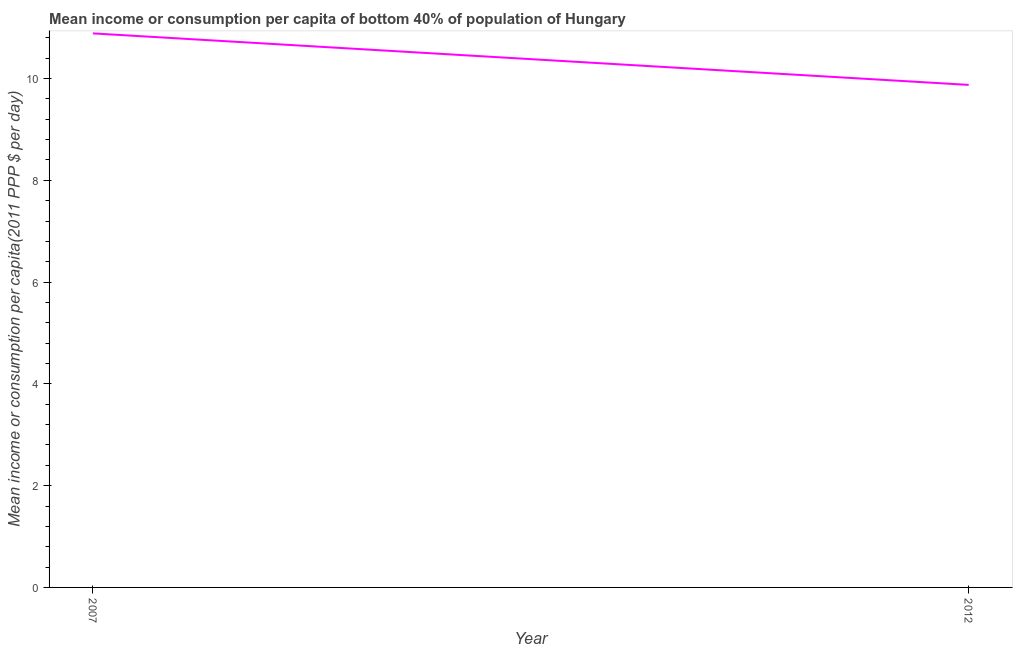What is the mean income or consumption in 2007?
Your answer should be compact. 10.89. Across all years, what is the maximum mean income or consumption?
Your answer should be very brief. 10.89. Across all years, what is the minimum mean income or consumption?
Offer a very short reply. 9.88. In which year was the mean income or consumption minimum?
Your response must be concise. 2012. What is the sum of the mean income or consumption?
Provide a short and direct response. 20.76. What is the difference between the mean income or consumption in 2007 and 2012?
Keep it short and to the point. 1.01. What is the average mean income or consumption per year?
Provide a short and direct response. 10.38. What is the median mean income or consumption?
Offer a very short reply. 10.38. Do a majority of the years between 2012 and 2007 (inclusive) have mean income or consumption greater than 6.8 $?
Offer a terse response. No. What is the ratio of the mean income or consumption in 2007 to that in 2012?
Your response must be concise. 1.1. In how many years, is the mean income or consumption greater than the average mean income or consumption taken over all years?
Offer a very short reply. 1. Does the mean income or consumption monotonically increase over the years?
Provide a short and direct response. No. How many lines are there?
Your answer should be very brief. 1. What is the difference between two consecutive major ticks on the Y-axis?
Offer a very short reply. 2. Are the values on the major ticks of Y-axis written in scientific E-notation?
Make the answer very short. No. What is the title of the graph?
Offer a terse response. Mean income or consumption per capita of bottom 40% of population of Hungary. What is the label or title of the Y-axis?
Keep it short and to the point. Mean income or consumption per capita(2011 PPP $ per day). What is the Mean income or consumption per capita(2011 PPP $ per day) of 2007?
Your answer should be very brief. 10.89. What is the Mean income or consumption per capita(2011 PPP $ per day) of 2012?
Your response must be concise. 9.88. What is the difference between the Mean income or consumption per capita(2011 PPP $ per day) in 2007 and 2012?
Your response must be concise. 1.01. What is the ratio of the Mean income or consumption per capita(2011 PPP $ per day) in 2007 to that in 2012?
Make the answer very short. 1.1. 